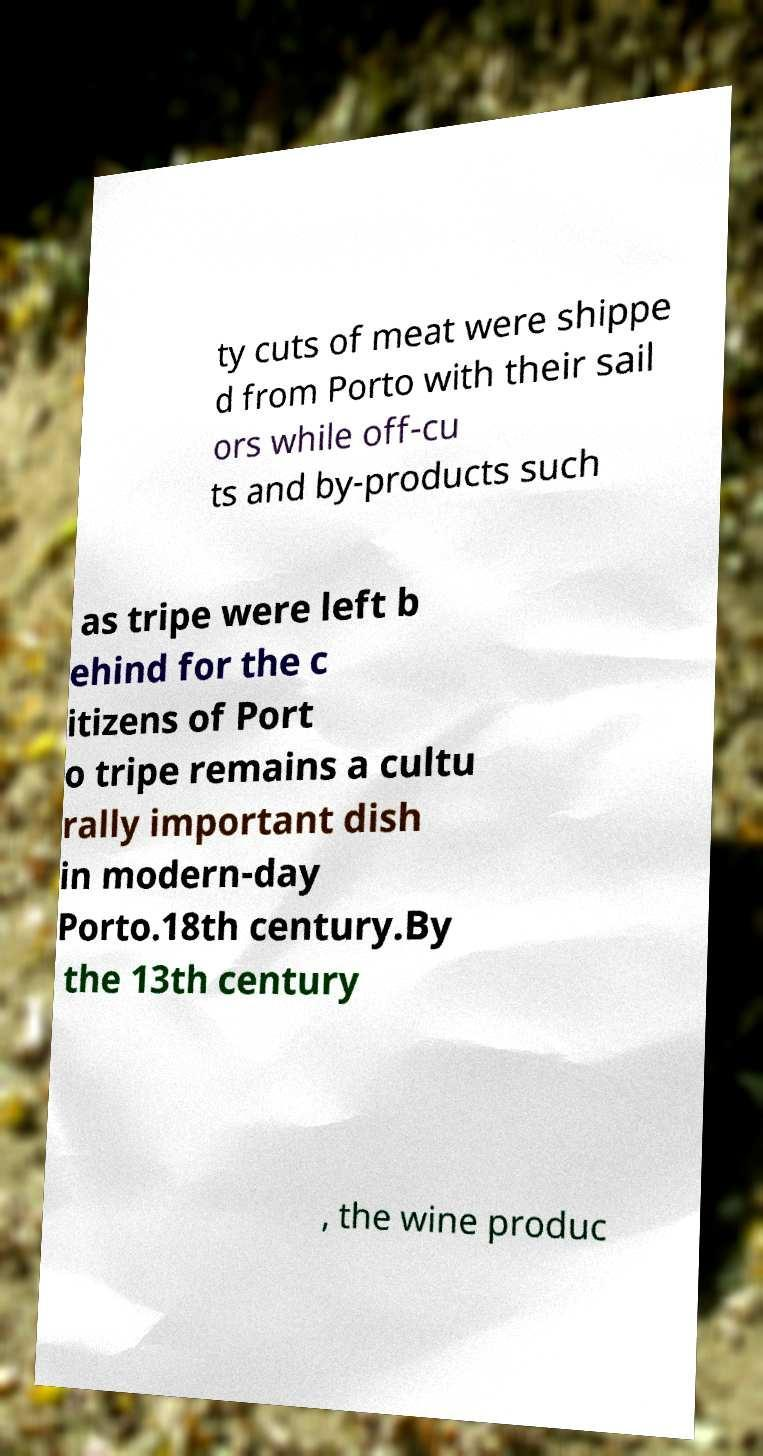There's text embedded in this image that I need extracted. Can you transcribe it verbatim? ty cuts of meat were shippe d from Porto with their sail ors while off-cu ts and by-products such as tripe were left b ehind for the c itizens of Port o tripe remains a cultu rally important dish in modern-day Porto.18th century.By the 13th century , the wine produc 